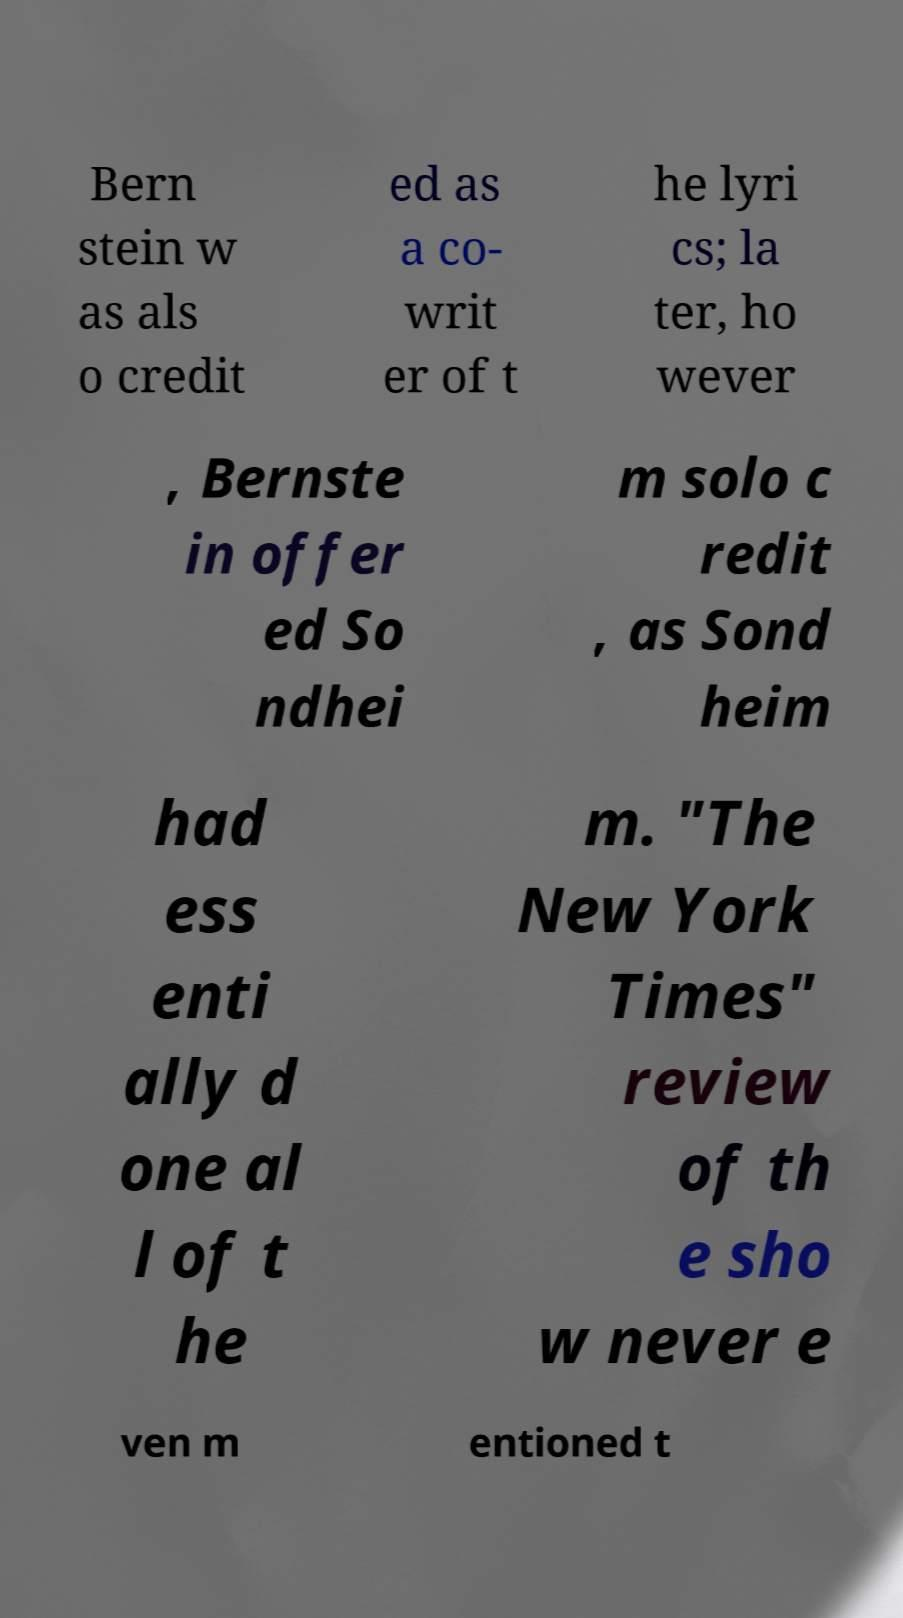I need the written content from this picture converted into text. Can you do that? Bern stein w as als o credit ed as a co- writ er of t he lyri cs; la ter, ho wever , Bernste in offer ed So ndhei m solo c redit , as Sond heim had ess enti ally d one al l of t he m. "The New York Times" review of th e sho w never e ven m entioned t 